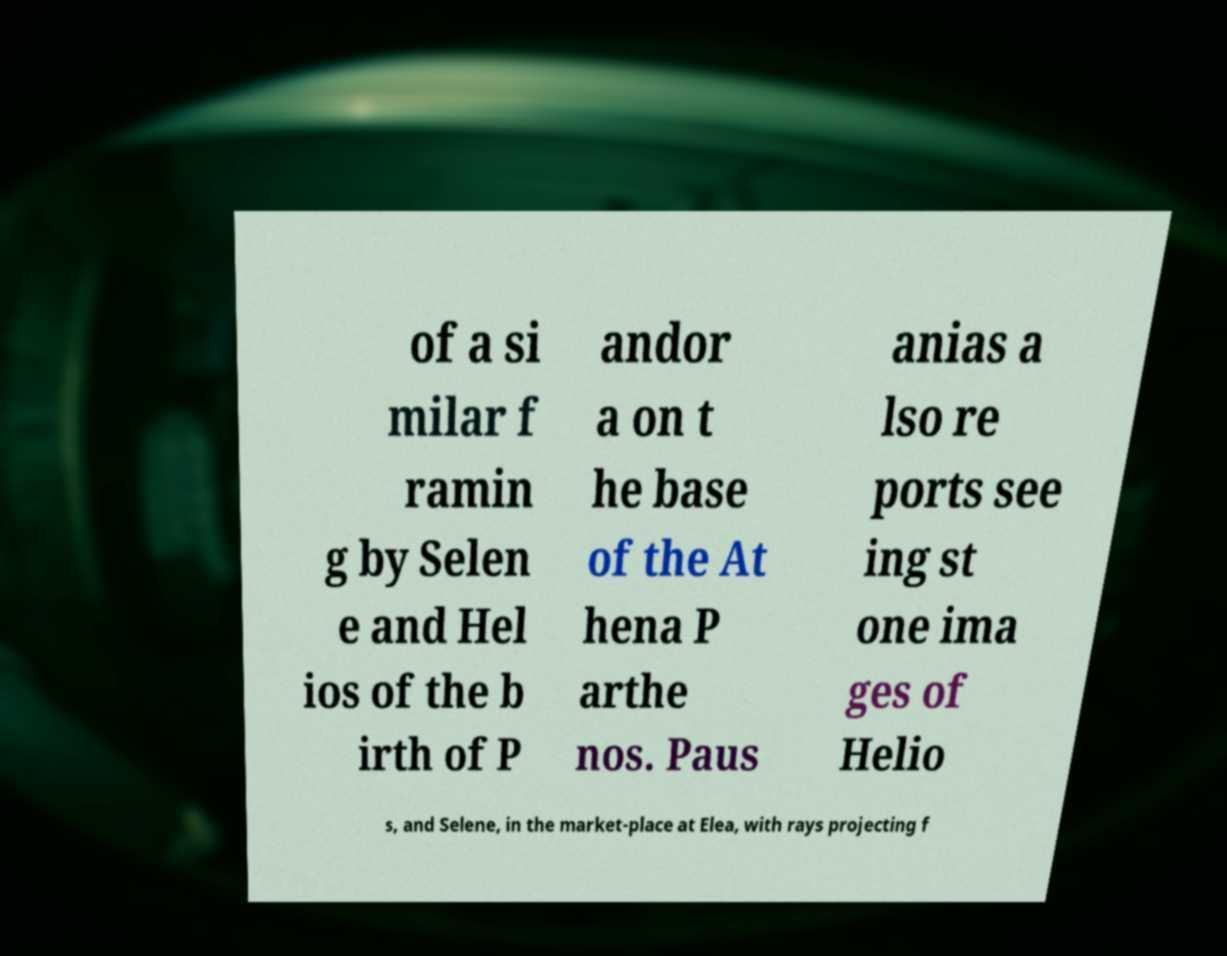Could you extract and type out the text from this image? of a si milar f ramin g by Selen e and Hel ios of the b irth of P andor a on t he base of the At hena P arthe nos. Paus anias a lso re ports see ing st one ima ges of Helio s, and Selene, in the market-place at Elea, with rays projecting f 